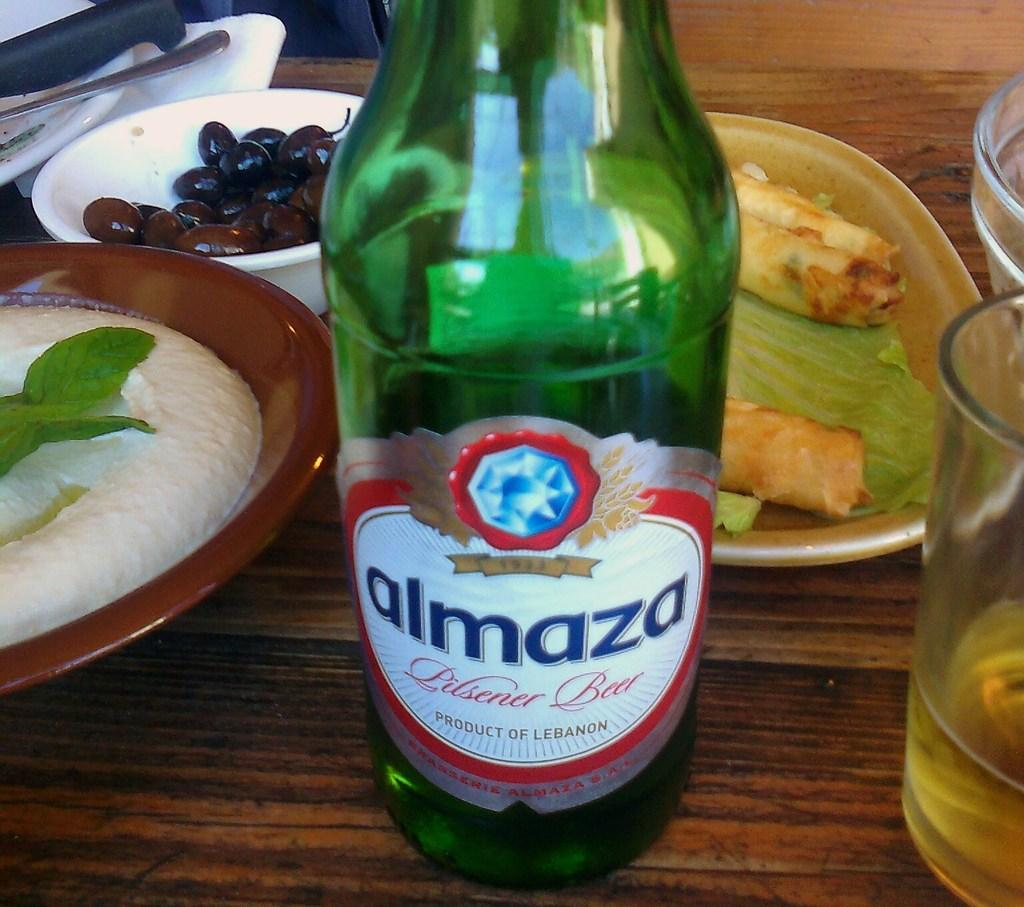<image>
Summarize the visual content of the image. An almaza beer bottle sits next to food dishes on a table. 